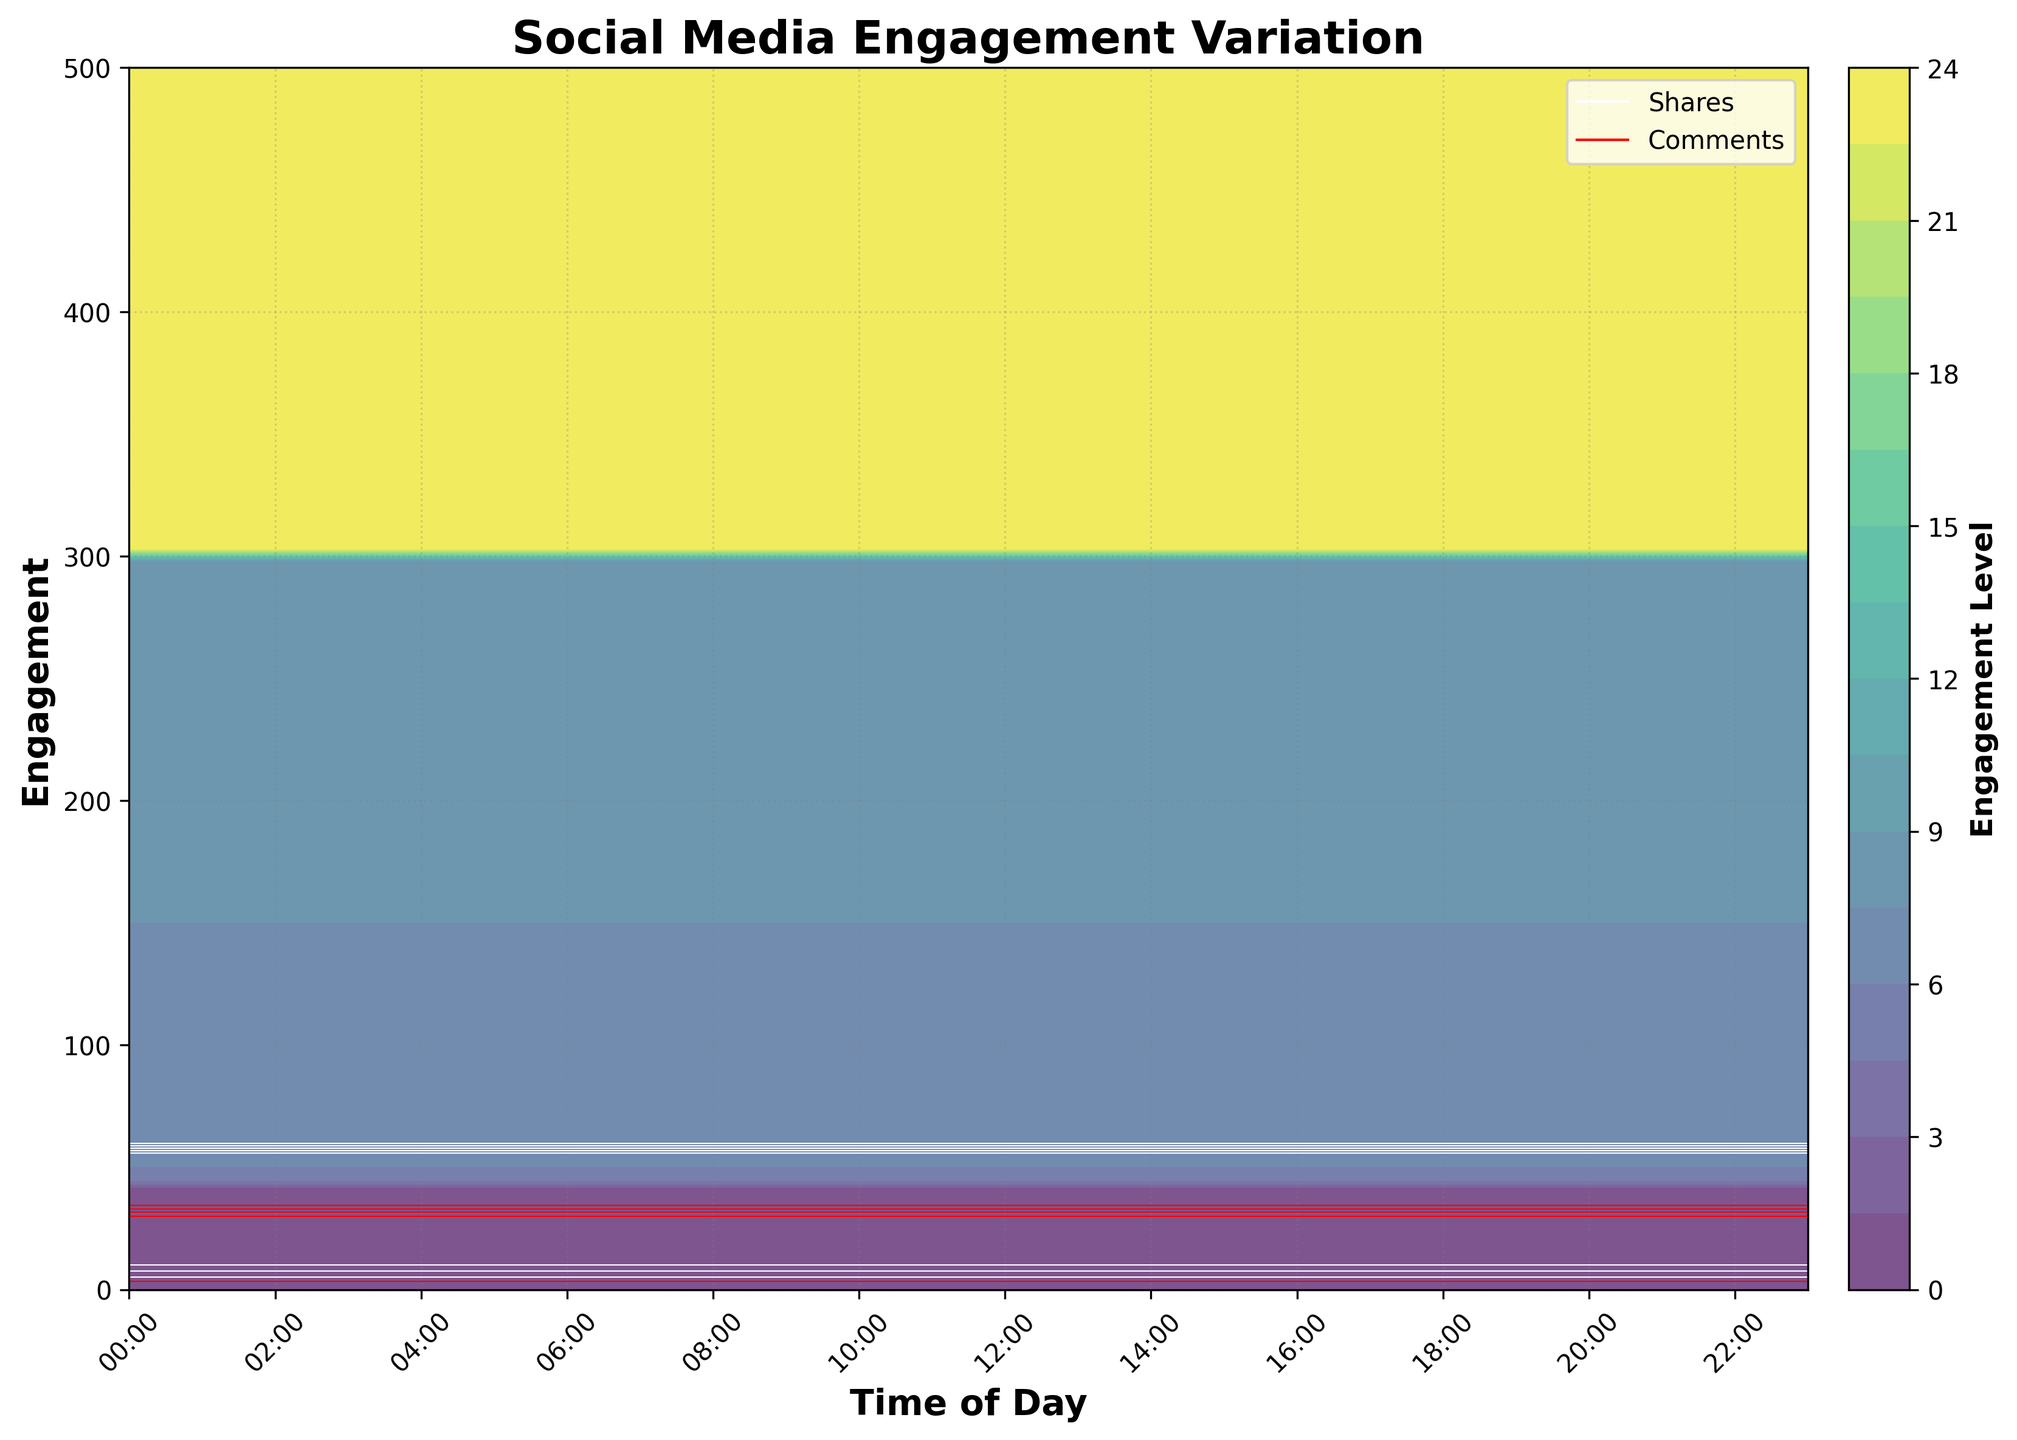What is the title of the plot? The title of the plot is usually written on top of the figure in bold. In this case, it mentions "Social Media Engagement Variation" which summarizes what the plot is about.
Answer: Social Media Engagement Variation How does the engagement level vary throughout the day? To understand this, observe the heat levels represented by the contour lines. Likes, shares, and comments all show higher engagement levels during the middle of the day (around 10:00 to 14:00) and lower engagement levels during early morning hours (00:00 to 05:00).
Answer: Higher during the day, lower in the early morning At what time of day does the number of likes peak? You can find this by looking for the highest level of likes, which corresponds to the darkest area in the contour plot. The highest engagement from likes seems to be centered around 13:00.
Answer: 13:00 During what range of times does the number of shares surpass 100? To answer this, observe the white contour lines indicating shares. The contour lines surpassing the 100 level are most prominent between 10:00 and 14:00.
Answer: 10:00 - 14:00 Are there any times when comments significantly drop? On the contour plot, look for areas where the red contour lines indicating comments are sparse or absent. Comments drop significantly from 00:00 to 05:00.
Answer: 00:00 - 05:00 What is the general trend for comments from morning to night? By observing the red contour lines for comments, the moments when the lines are further spaced out indicate lower comments, rising in density between 07:00 to 12:00 and then tapering off again after 21:00.
Answer: Increase in the morning, peak around midday, and reduce after 21:00 How do the likes compare to shares at 08:00? Look at the contour lines and colors around 08:00. Engagement for likes is much higher around 08:00 (near 200) whereas shares are considerably lower (around 50).
Answer: Likes are higher than shares Which type of engagement is the lowest at 04:00, and why? Check the contour lines and colors around 04:00. Engagement of all types is low, but by observing the levels, shares and comments have the fewest number of contour lines, showing very low engagement levels. Between these, comments are lower.
Answer: Comments What is the purpose of the colorbar, and what does it indicate? The colorbar is on the right side of the plot, indicating the variation in engagement level with a color gradient from purple (low) to yellow (high).
Answer: Indicates engagement level Between which hours is the engagement uniformly high across likes, shares, and comments? Look for the timeframe when all three contour sets (likes, shares, and comments) are densely packed and showing high engagement. This appears to be between 10:00 to 14:00.
Answer: 10:00 - 14:00 